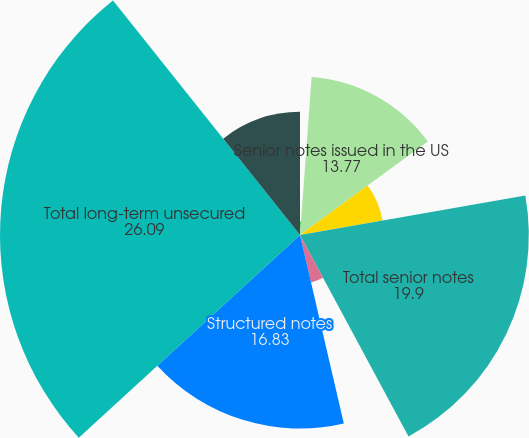Convert chart to OTSL. <chart><loc_0><loc_0><loc_500><loc_500><pie_chart><fcel>Year ended December 31 (in<fcel>Senior notes issued in the US<fcel>Senior notes issued in non-US<fcel>Total senior notes<fcel>Subordinated debt<fcel>Structured notes<fcel>Total long-term unsecured<fcel>Senior notes<nl><fcel>1.17%<fcel>13.77%<fcel>7.29%<fcel>19.9%<fcel>4.23%<fcel>16.83%<fcel>26.09%<fcel>10.71%<nl></chart> 